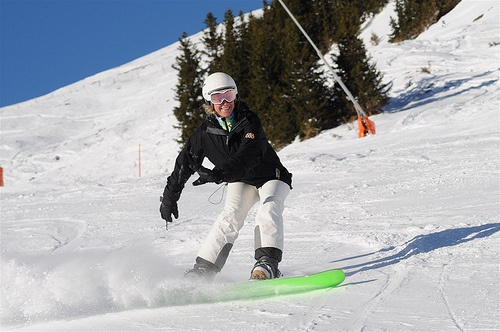Describe the objects in this image and their specific colors. I can see people in blue, black, lightgray, darkgray, and gray tones and snowboard in blue, lightgreen, darkgray, and lightgray tones in this image. 